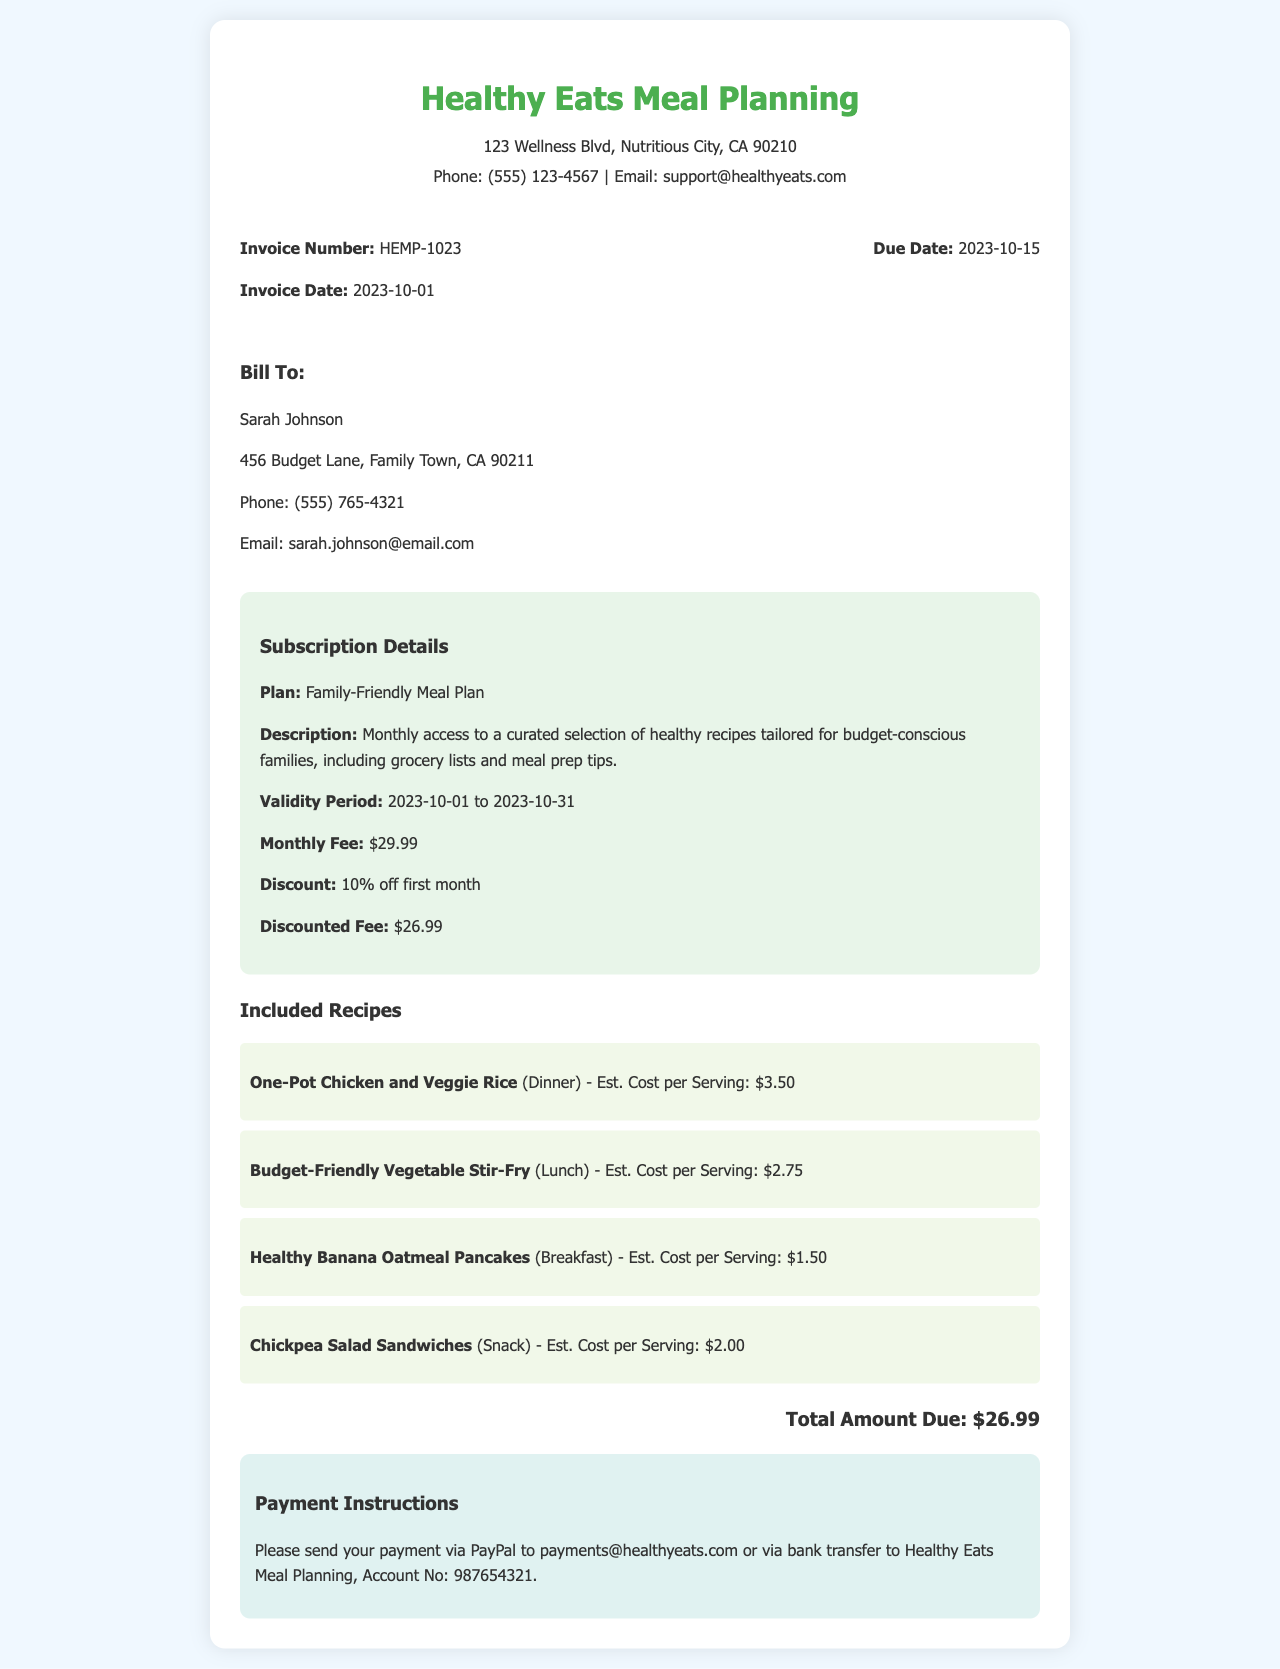What is the invoice number? The invoice number is indicated prominently near the top of the document, listed under the invoice details.
Answer: HEMP-1023 What is the discounted fee for the month's subscription? The discounted fee is shown in the subscription details section, reflecting a 10% discount.
Answer: $26.99 Who is the bill recipient? The bill recipient's name is clearly stated in the client details section of the invoice.
Answer: Sarah Johnson What is the validity period of the subscription? The validity period is mentioned in the subscription details, indicating the start and end date of the subscription.
Answer: 2023-10-01 to 2023-10-31 What is one of the included recipes? One recipe is provided under the included recipes section, showcasing options available in the meal plan.
Answer: One-Pot Chicken and Veggie Rice What was the original monthly fee? The original monthly fee can be found in the subscription details before applying the discount.
Answer: $29.99 When is the payment due date? The due date is specified in the invoice details section, indicating when payment must be made.
Answer: 2023-10-15 What payment methods are provided? The payment instructions section outlines how payments can be made, indicating available methods.
Answer: PayPal or bank transfer What is the estimated cost per serving for Healthy Banana Oatmeal Pancakes? The estimated cost per serving is stated in the recipes section, detailing financial information for each recipe.
Answer: $1.50 